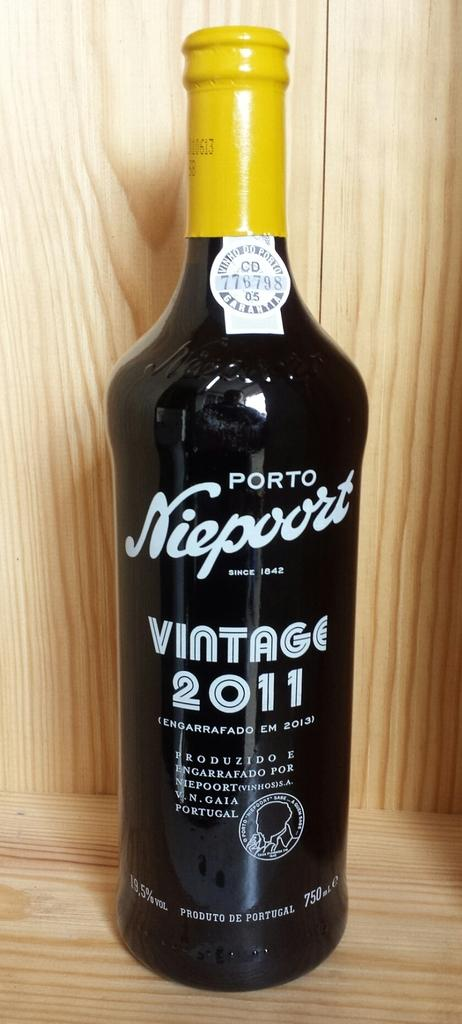<image>
Write a terse but informative summary of the picture. Porto Niesport wine bottle with yellow top on a wooden surface. 